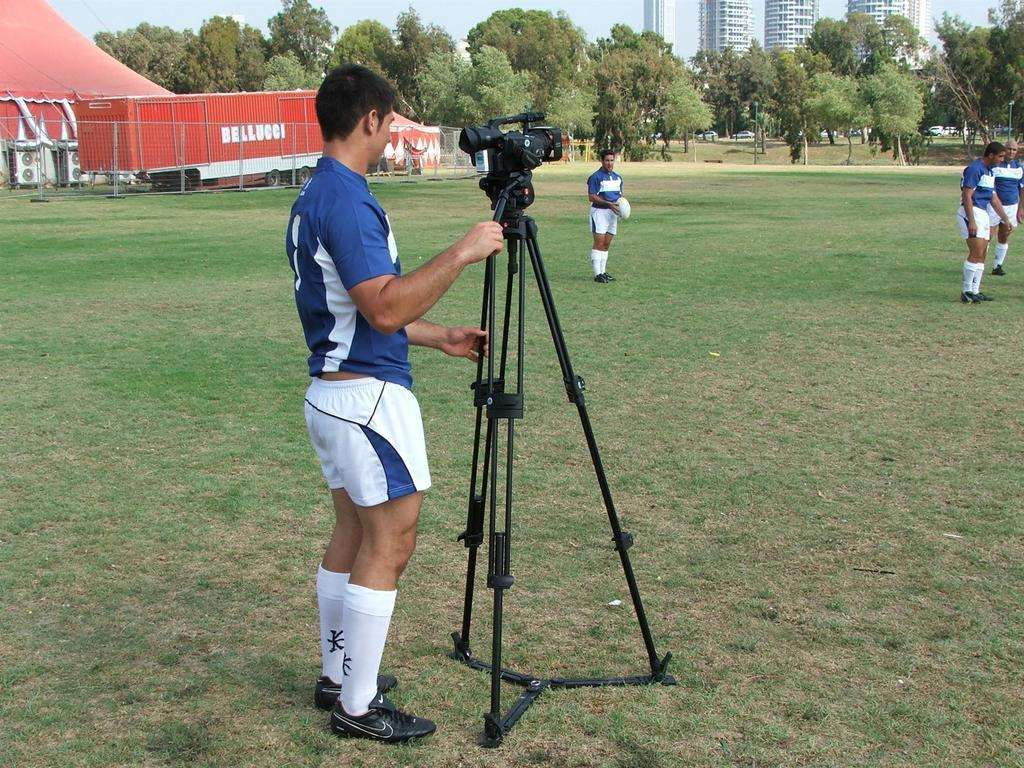What is the man in the image doing? The man is standing on the grass and holding a video camera with a stand. What can be seen in the background of the image? Red tents, vehicles, trees, buildings, and some people are visible in the background. What type of terrain is the man standing on? The man is standing on grass. What is the man holding in his hand? The man is holding a video camera with a stand. What type of frog can be seen jumping near the man in the image? There is no frog present in the image. What type of farm animals can be seen in the image? There are no farm animals visible in the image. 